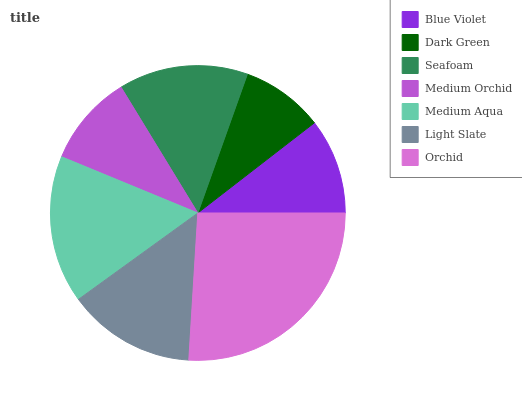Is Dark Green the minimum?
Answer yes or no. Yes. Is Orchid the maximum?
Answer yes or no. Yes. Is Seafoam the minimum?
Answer yes or no. No. Is Seafoam the maximum?
Answer yes or no. No. Is Seafoam greater than Dark Green?
Answer yes or no. Yes. Is Dark Green less than Seafoam?
Answer yes or no. Yes. Is Dark Green greater than Seafoam?
Answer yes or no. No. Is Seafoam less than Dark Green?
Answer yes or no. No. Is Light Slate the high median?
Answer yes or no. Yes. Is Light Slate the low median?
Answer yes or no. Yes. Is Blue Violet the high median?
Answer yes or no. No. Is Blue Violet the low median?
Answer yes or no. No. 